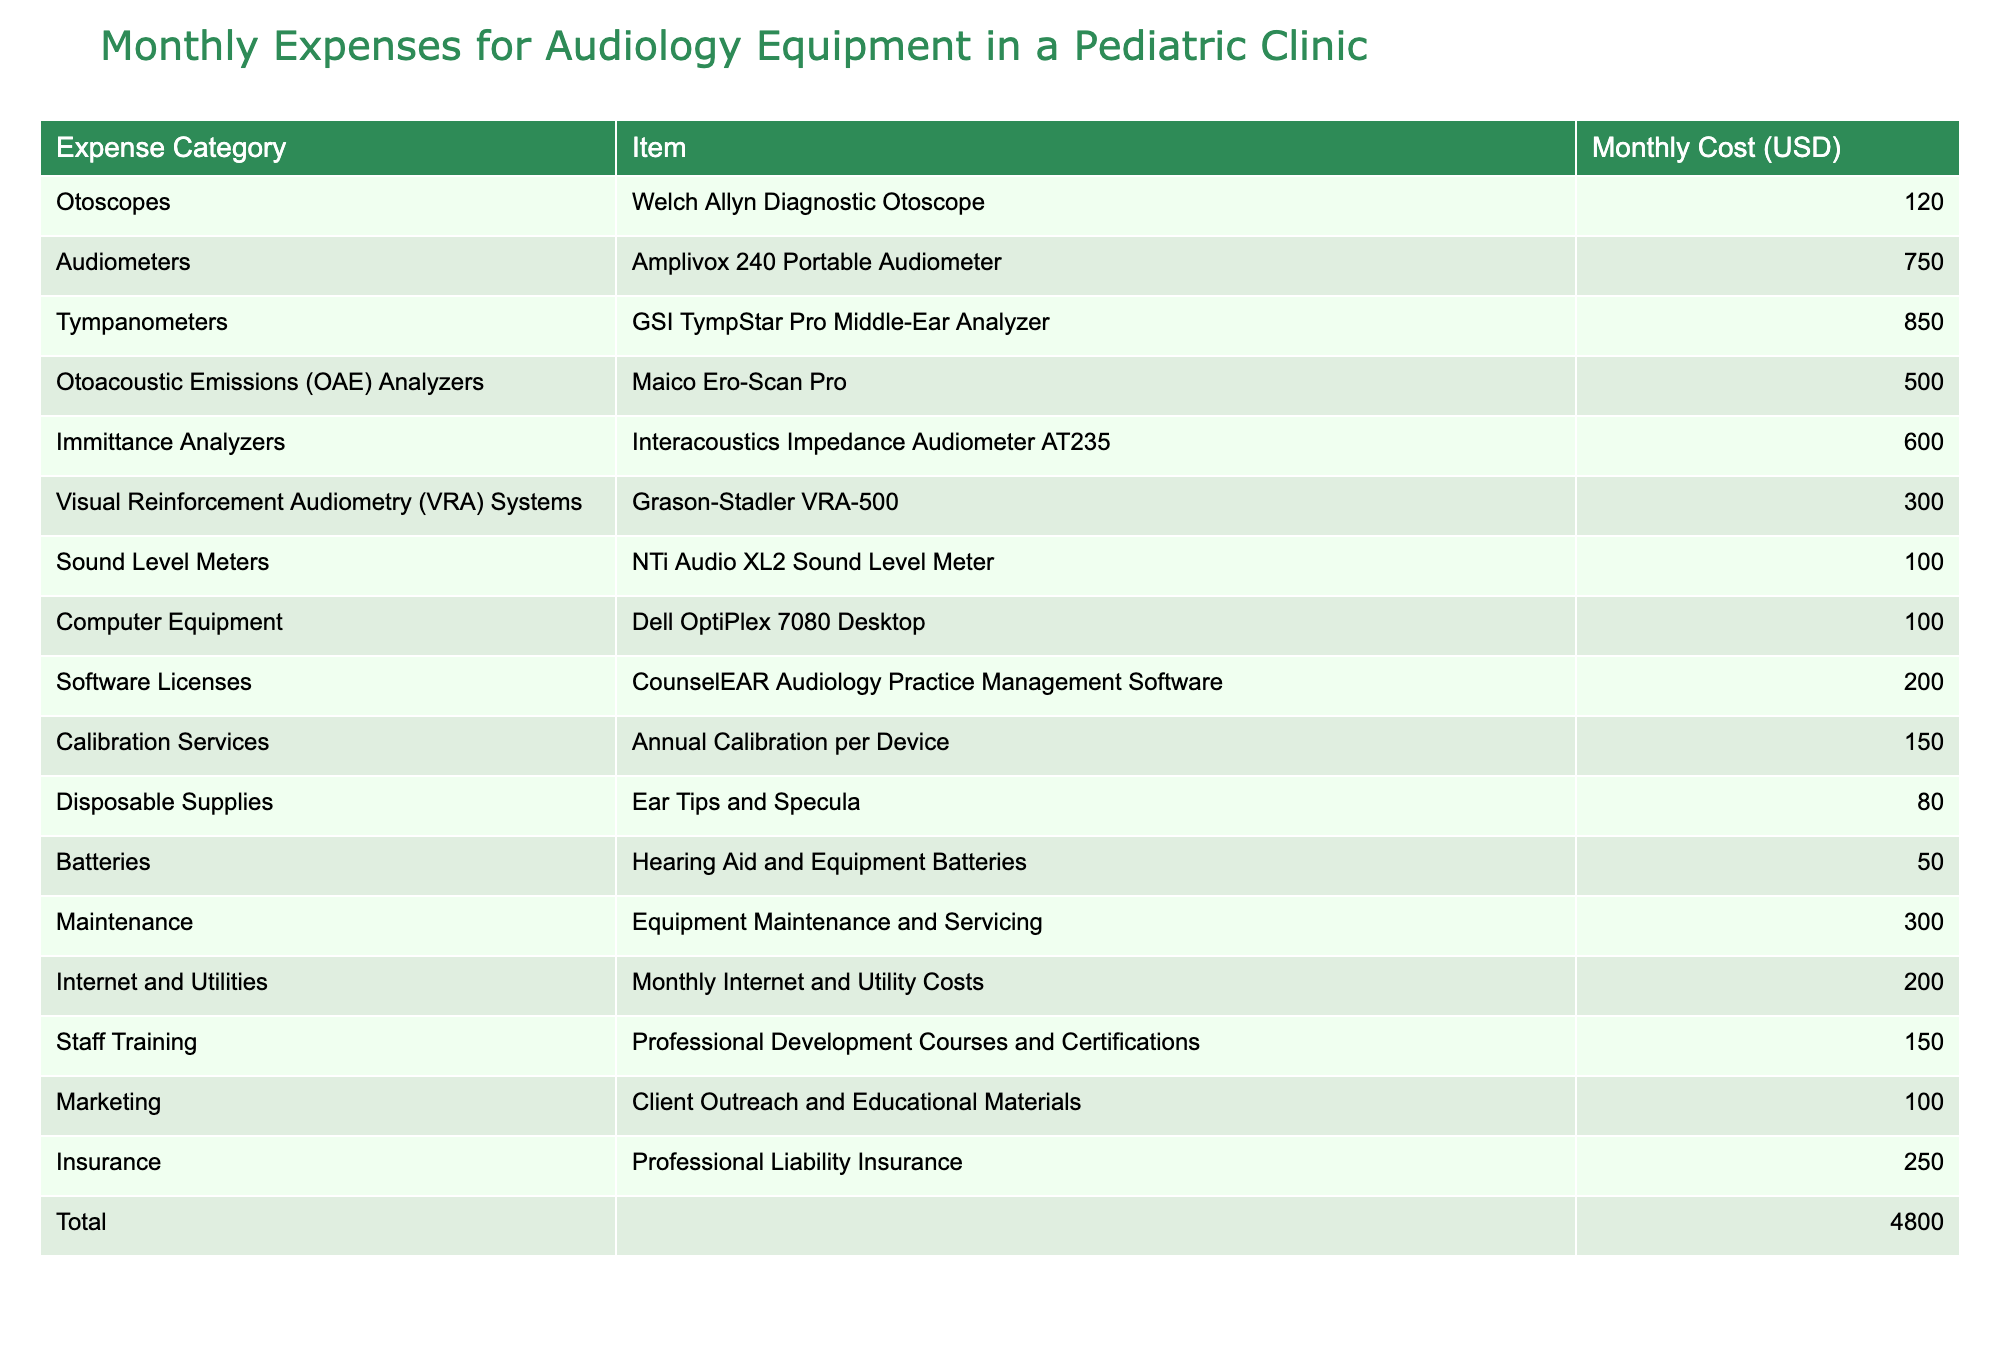What is the total monthly cost of audiology equipment in the clinic? By looking at the "Total" row in the table, we can directly see the monthly cost for all expenses combined. It sums all monthly expenses listed above, which amounts to 4,250 USD.
Answer: 4,250 USD Which item has the highest monthly cost? Checking the "Monthly Cost (USD)" column for the highest value, we find that the GSI TympStar Pro Middle-Ear Analyzer has the highest cost at 850 USD.
Answer: GSI TympStar Pro Middle-Ear Analyzer What is the combined cost of batteries and disposable supplies? We first identify the monthly costs for batteries, which are 50 USD, and for disposable supplies, which are 80 USD. Adding these two amounts together gives 50 + 80 = 130 USD.
Answer: 130 USD Is the monthly cost for visual reinforcement audiometry systems greater than the cost for sound level meters? The VRA system costs 300 USD, and the sound level meter costs 100 USD. Since 300 is greater than 100, the statement is true.
Answer: Yes What is the average monthly cost of all the equipment items listed? We count the number of items, which is 14 (excluding the total). The total monthly cost is 4,250 USD. To find the average, we divide 4,250 by 14, which equals approximately 303.57 USD.
Answer: 303.57 USD How much more does maintenance cost compared to batteries? The maintenance cost is 300 USD, and the battery cost is 50 USD. The difference is calculated by subtracting 50 from 300, resulting in 250 USD more for maintenance.
Answer: 250 USD Does the clinic allocate more expenses to software licenses than to calibration services? The software license costs 200 USD, while calibration services cost 150 USD. Since 200 is greater than 150, the answer is yes.
Answer: Yes What are the total costs for the categories related to measurements (Tympanometers, Audiometers, OAE Analyzers, and Immittance Analyzers)? We sum the costs: Tympanometers (850) + Audiometers (750) + OAE Analyzers (500) + Immittance Analyzers (600) equals 2,700 USD for measuring equipment.
Answer: 2,700 USD How does the cost of staff training compare to the monthly internet and utilities expenses? The staff training costs 150 USD while the internet and utilities cost 200 USD. Since 150 is less than 200, staff training costs less.
Answer: Staff training costs less 